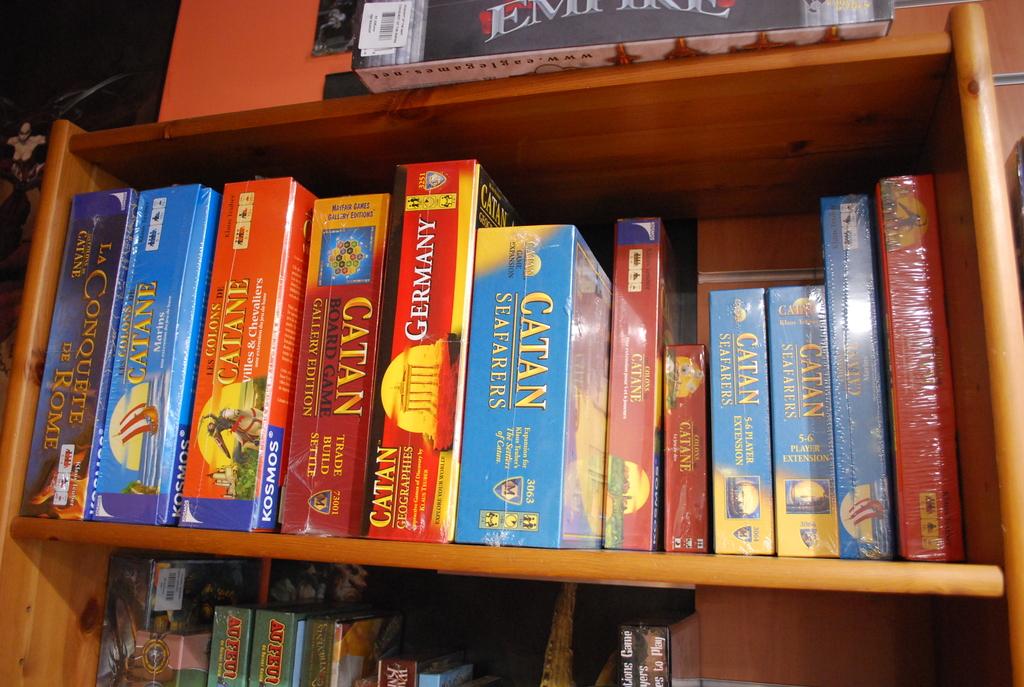What country is the red book in the center about?
Your answer should be compact. Germany. What city is on the book all the way to the left?
Give a very brief answer. Rome. 